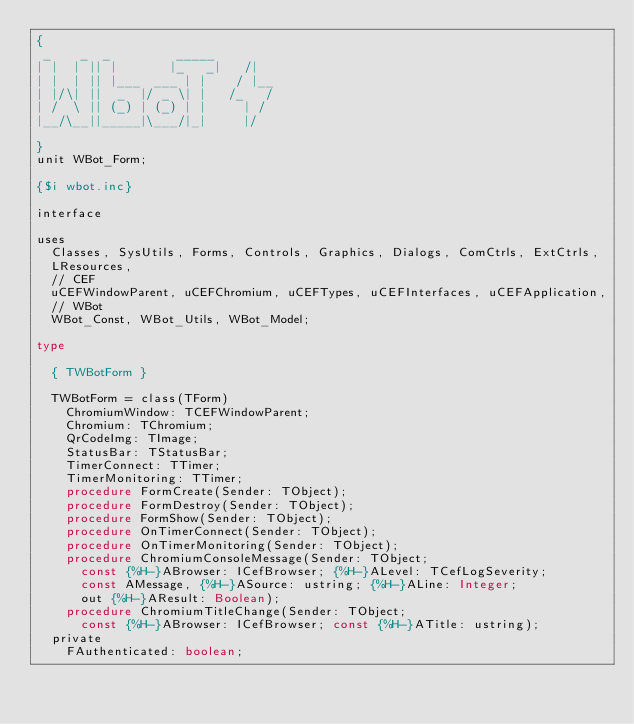Convert code to text. <code><loc_0><loc_0><loc_500><loc_500><_Pascal_>{
 _    _  _         _____
| |  | || |       |_   _|   /|
| |  | || |___  ___ | |    / |__
| |/\| ||  _  |/ _ \| |   /_   /
| /  \ || (_) | (_) | |     | /
|__/\__||_____|\___/|_|     |/

}
unit WBot_Form;

{$i wbot.inc}

interface

uses
  Classes, SysUtils, Forms, Controls, Graphics, Dialogs, ComCtrls, ExtCtrls,
  LResources,
  // CEF
  uCEFWindowParent, uCEFChromium, uCEFTypes, uCEFInterfaces, uCEFApplication,
  // WBot
  WBot_Const, WBot_Utils, WBot_Model;

type

  { TWBotForm }

  TWBotForm = class(TForm)
    ChromiumWindow: TCEFWindowParent;
    Chromium: TChromium;
    QrCodeImg: TImage;
    StatusBar: TStatusBar;
    TimerConnect: TTimer;
    TimerMonitoring: TTimer;
    procedure FormCreate(Sender: TObject);
    procedure FormDestroy(Sender: TObject);  
    procedure FormShow(Sender: TObject);  
    procedure OnTimerConnect(Sender: TObject);
    procedure OnTimerMonitoring(Sender: TObject);
    procedure ChromiumConsoleMessage(Sender: TObject;
      const {%H-}ABrowser: ICefBrowser; {%H-}ALevel: TCefLogSeverity;
      const AMessage, {%H-}ASource: ustring; {%H-}ALine: Integer;
      out {%H-}AResult: Boolean);
    procedure ChromiumTitleChange(Sender: TObject;
      const {%H-}ABrowser: ICefBrowser; const {%H-}ATitle: ustring);
  private
    FAuthenticated: boolean;</code> 